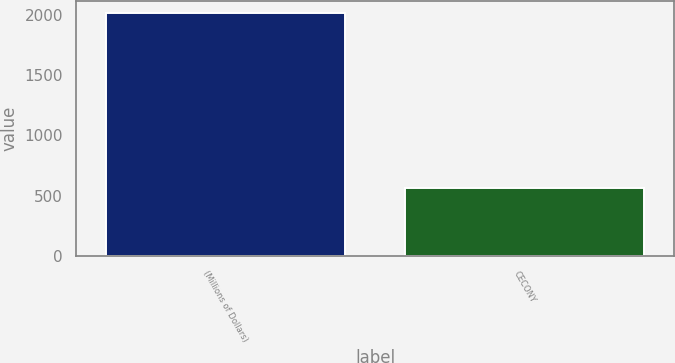Convert chart to OTSL. <chart><loc_0><loc_0><loc_500><loc_500><bar_chart><fcel>(Millions of Dollars)<fcel>CECONY<nl><fcel>2015<fcel>567<nl></chart> 